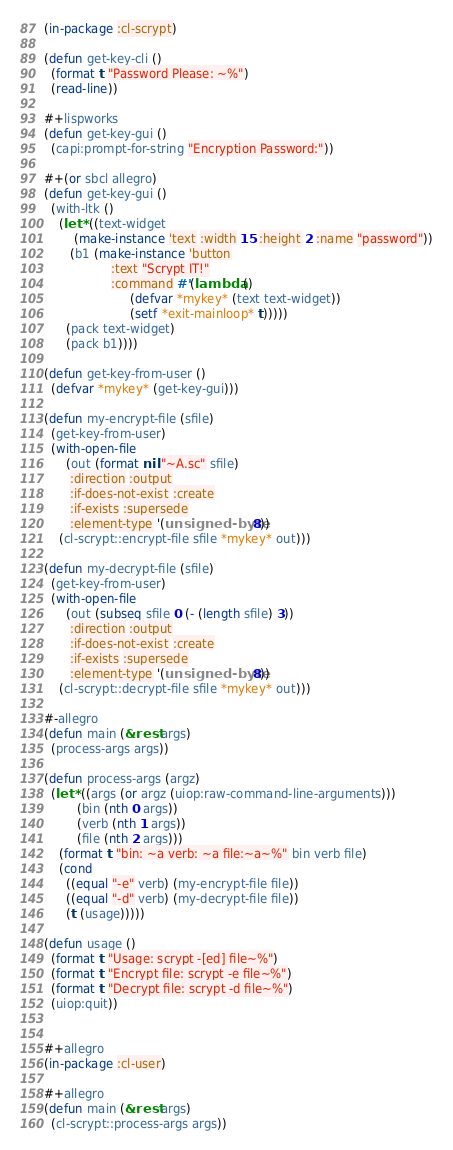Convert code to text. <code><loc_0><loc_0><loc_500><loc_500><_Lisp_>(in-package :cl-scrypt)

(defun get-key-cli ()
  (format t "Password Please: ~%")
  (read-line))

#+lispworks
(defun get-key-gui ()
  (capi:prompt-for-string "Encryption Password:"))

#+(or sbcl allegro)
(defun get-key-gui ()
  (with-ltk ()
    (let* ((text-widget
	    (make-instance 'text :width 15 :height 2 :name "password"))
	   (b1 (make-instance 'button
			      :text "Scrypt IT!"
			      :command #'(lambda ()
					   (defvar *mykey* (text text-widget))
					   (setf *exit-mainloop* t)))))
      (pack text-widget)
      (pack b1))))

(defun get-key-from-user ()
  (defvar *mykey* (get-key-gui)))

(defun my-encrypt-file (sfile)
  (get-key-from-user)
  (with-open-file
      (out (format nil "~A.sc" sfile)
	   :direction :output
	   :if-does-not-exist :create
	   :if-exists :supersede
	   :element-type '(unsigned-byte 8))
    (cl-scrypt::encrypt-file sfile *mykey* out)))

(defun my-decrypt-file (sfile)
  (get-key-from-user)
  (with-open-file
      (out (subseq sfile 0 (- (length sfile) 3))
	   :direction :output
	   :if-does-not-exist :create
	   :if-exists :supersede
	   :element-type '(unsigned-byte 8))
    (cl-scrypt::decrypt-file sfile *mykey* out)))

#-allegro
(defun main (&rest args)
  (process-args args))

(defun process-args (argz)
  (let* ((args (or argz (uiop:raw-command-line-arguments)))
         (bin (nth 0 args))
         (verb (nth 1 args))
         (file (nth 2 args)))
    (format t "bin: ~a verb: ~a file:~a~%" bin verb file)
    (cond
      ((equal "-e" verb) (my-encrypt-file file))
      ((equal "-d" verb) (my-decrypt-file file))
      (t (usage)))))

(defun usage ()
  (format t "Usage: scrypt -[ed] file~%")
  (format t "Encrypt file: scrypt -e file~%")
  (format t "Decrypt file: scrypt -d file~%")
  (uiop:quit))


#+allegro
(in-package :cl-user)

#+allegro
(defun main (&rest args)
  (cl-scrypt::process-args args))
</code> 